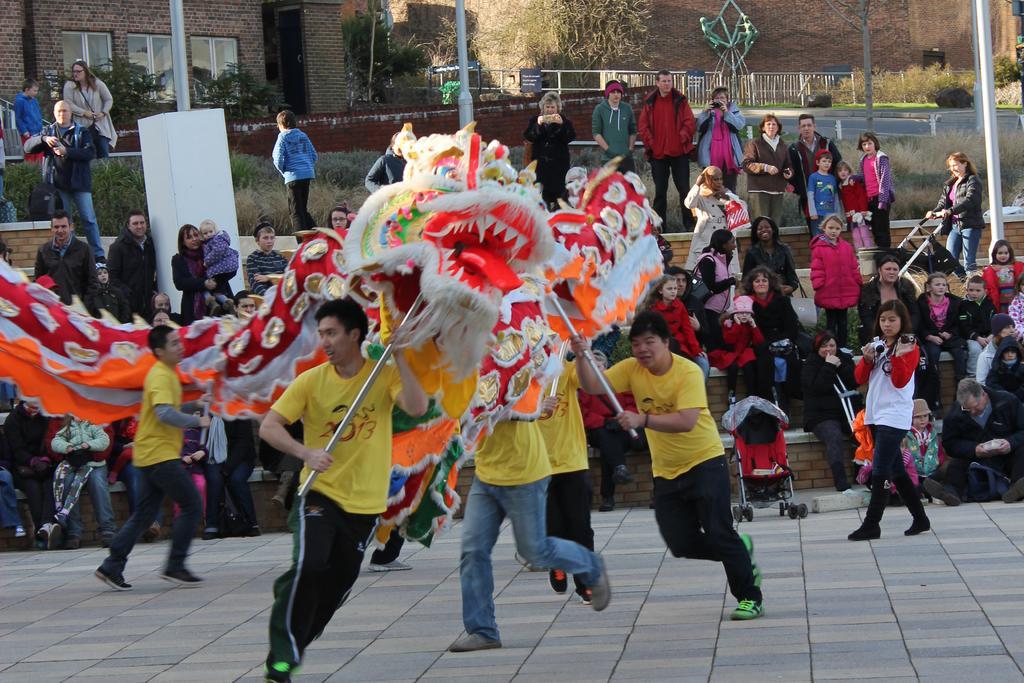Can you describe this image briefly? In this image, we can see some people walking, there are some people sitting and watching, we can see some people standing, in the background, we can see the wall with windows, we can see the poles. 